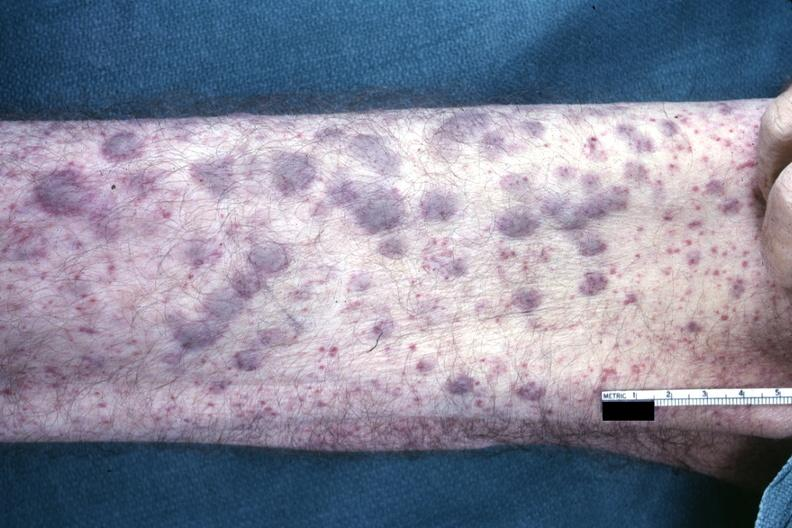does this image show?
Answer the question using a single word or phrase. Yes 